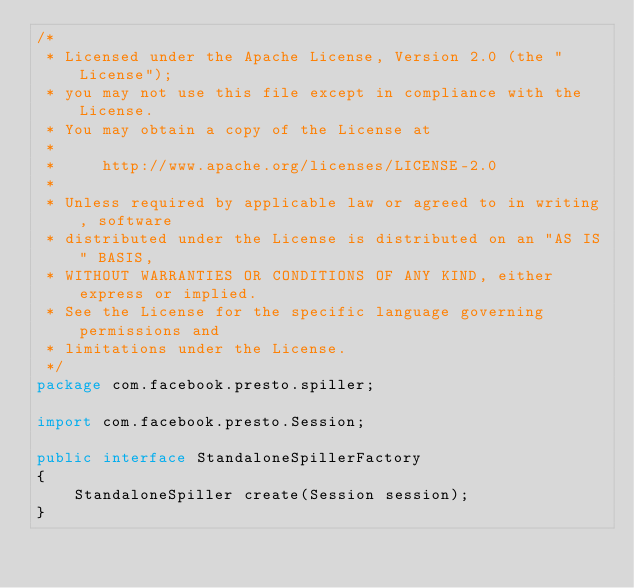Convert code to text. <code><loc_0><loc_0><loc_500><loc_500><_Java_>/*
 * Licensed under the Apache License, Version 2.0 (the "License");
 * you may not use this file except in compliance with the License.
 * You may obtain a copy of the License at
 *
 *     http://www.apache.org/licenses/LICENSE-2.0
 *
 * Unless required by applicable law or agreed to in writing, software
 * distributed under the License is distributed on an "AS IS" BASIS,
 * WITHOUT WARRANTIES OR CONDITIONS OF ANY KIND, either express or implied.
 * See the License for the specific language governing permissions and
 * limitations under the License.
 */
package com.facebook.presto.spiller;

import com.facebook.presto.Session;

public interface StandaloneSpillerFactory
{
    StandaloneSpiller create(Session session);
}
</code> 